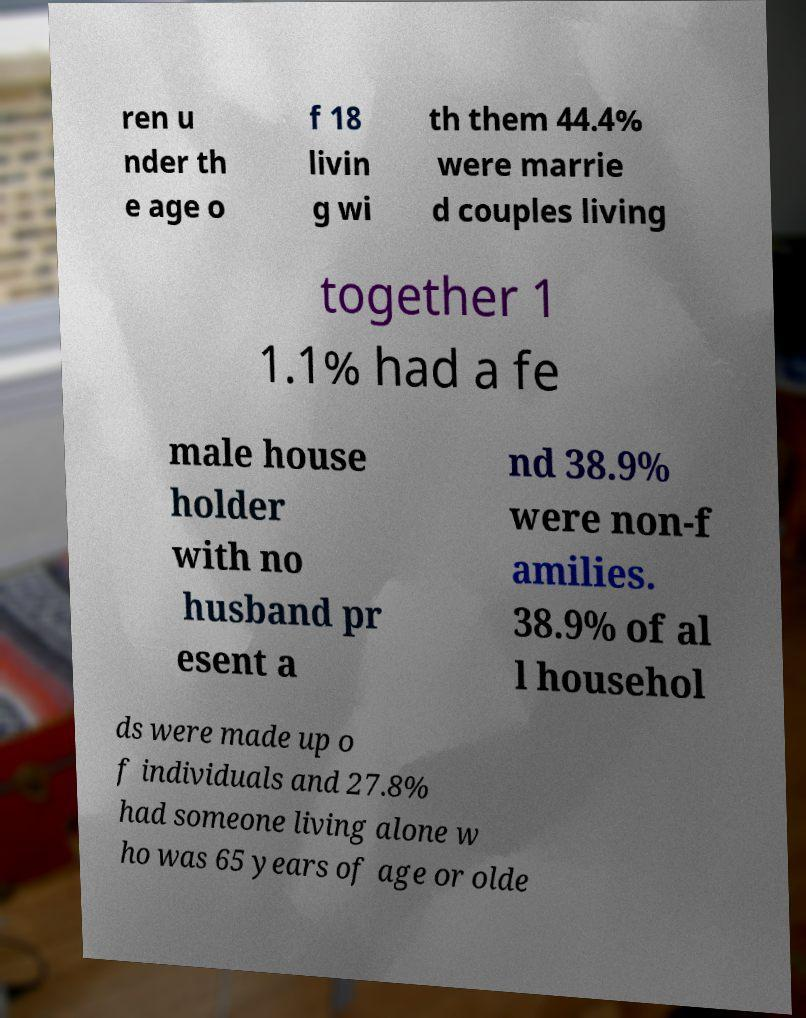There's text embedded in this image that I need extracted. Can you transcribe it verbatim? ren u nder th e age o f 18 livin g wi th them 44.4% were marrie d couples living together 1 1.1% had a fe male house holder with no husband pr esent a nd 38.9% were non-f amilies. 38.9% of al l househol ds were made up o f individuals and 27.8% had someone living alone w ho was 65 years of age or olde 